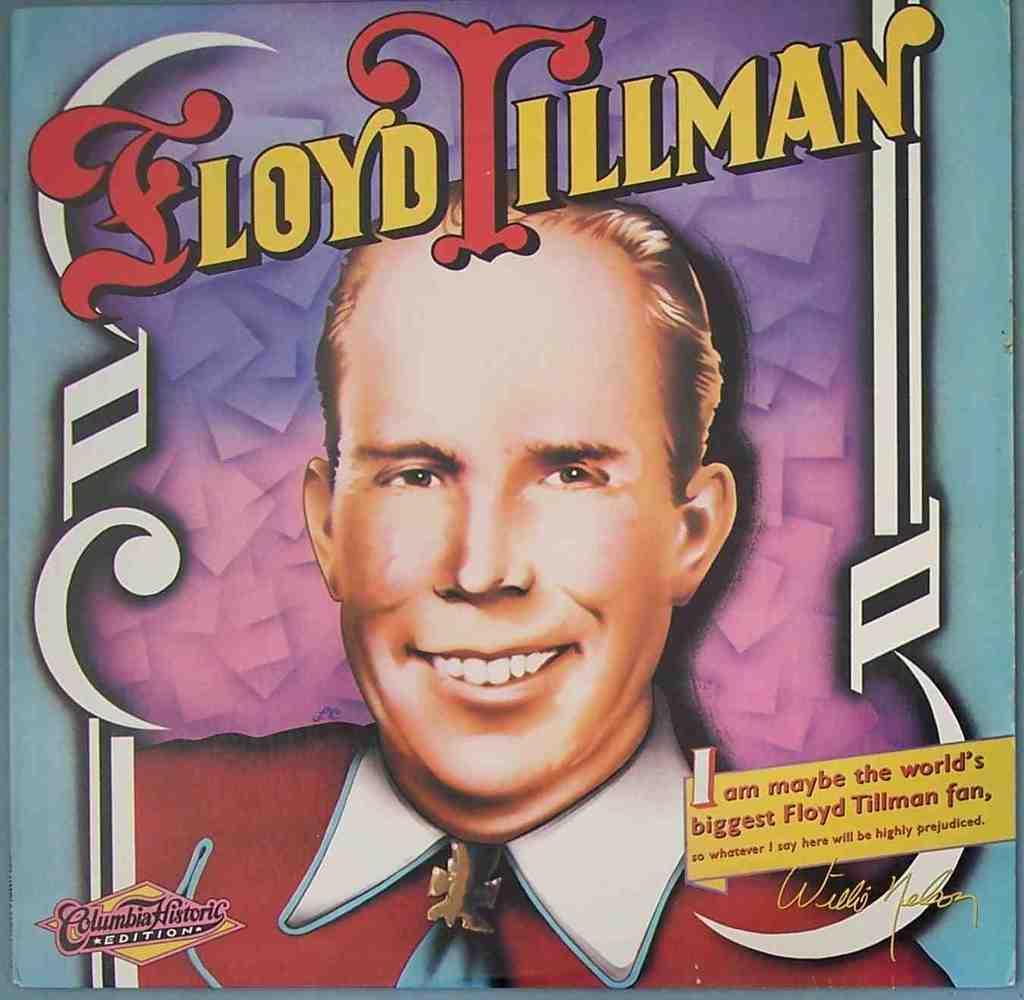Describe this image in one or two sentences. This is a man wearing red shirt. 